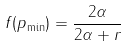<formula> <loc_0><loc_0><loc_500><loc_500>f ( p _ { \min } ) = \frac { 2 \alpha } { 2 \alpha + r }</formula> 